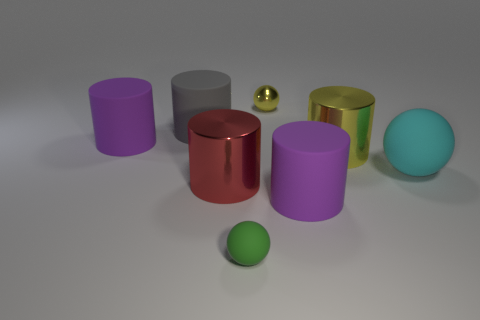Subtract 2 cylinders. How many cylinders are left? 3 Subtract all gray cylinders. How many cylinders are left? 4 Subtract all yellow cylinders. How many cylinders are left? 4 Subtract all green cylinders. Subtract all yellow blocks. How many cylinders are left? 5 Add 1 large metallic things. How many objects exist? 9 Subtract all cylinders. How many objects are left? 3 Add 2 green rubber things. How many green rubber things are left? 3 Add 6 tiny green spheres. How many tiny green spheres exist? 7 Subtract 1 red cylinders. How many objects are left? 7 Subtract all green balls. Subtract all green objects. How many objects are left? 6 